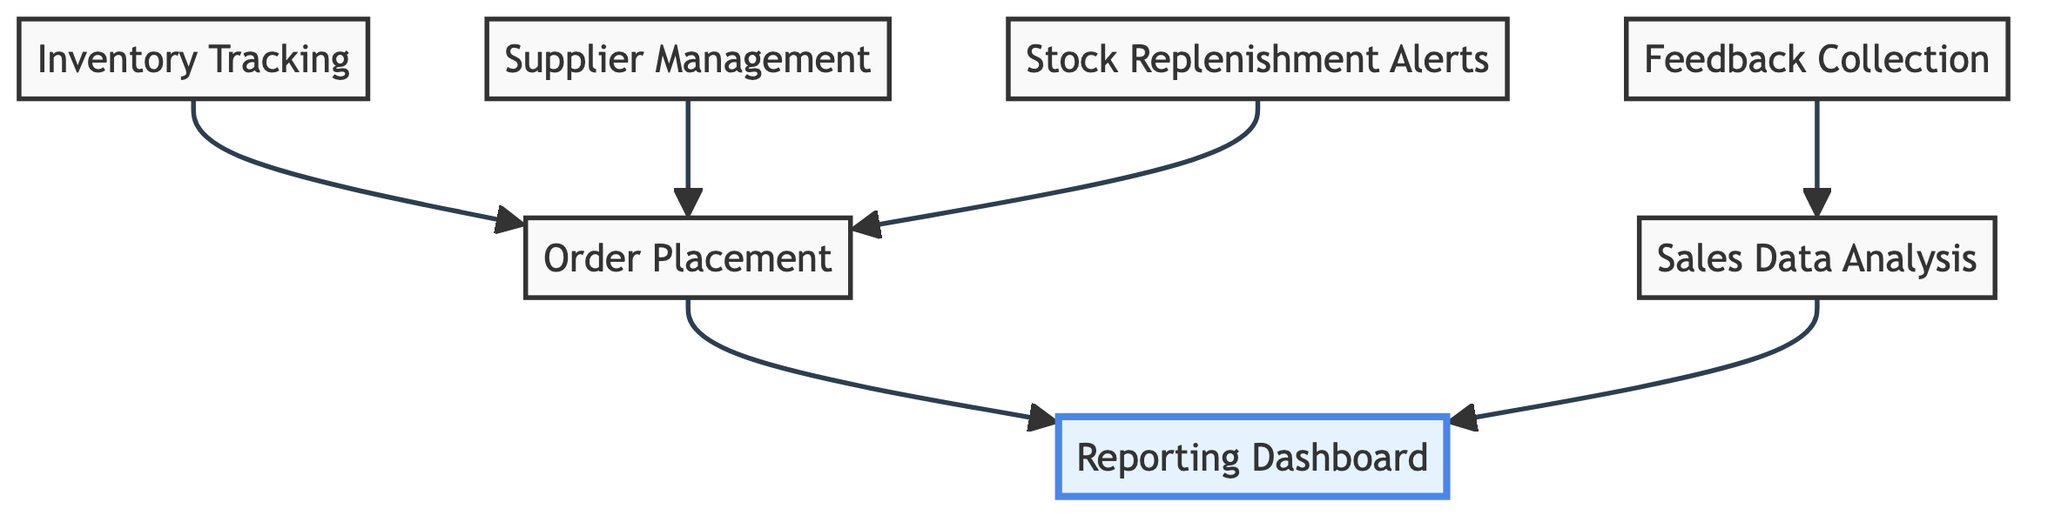What is the highest level node in the diagram? The highest level node is the "Reporting Dashboard," which is visually represented at the top position in the flowchart. It is designed to aggregate the data from other processes in the inventory management system.
Answer: Reporting Dashboard How many nodes are in the diagram? The diagram contains a total of 7 nodes, which represent various components of the inventory management system. This includes each process involved in managing inventory and supplier relationships.
Answer: 7 What does "Stock Replenishment Alerts" connect to? "Stock Replenishment Alerts" connects to "Order Placement," indicating that stock alerts are directly tied to the process of placing new orders based on alert conditions.
Answer: Order Placement Which node plays a role in both "Feedback Collection" and "Sales Data Analysis"? "Sales Data Analysis" is connected to "Feedback Collection," indicating that feedback from teachers could inform analysis of sales data for improved inventory forecasting.
Answer: Sales Data Analysis What relationship exists between "Supplier Management" and "Order Placement"? "Supplier Management" is directly linked to "Order Placement," meaning that managing relationships with suppliers is essential for processing orders for inventory.
Answer: Direct connection What is the purpose of "Inventory Tracking"? The purpose of "Inventory Tracking" is to monitor stock levels in real-time, which is crucial for effective management of educational supplies.
Answer: Monitor stock levels Which node is at the bottom of the flowchart? "Reporting Dashboard" is the bottom node in the hierarchy of processes, signifying that it consolidates the results from other nodes for reporting purposes.
Answer: Reporting Dashboard 